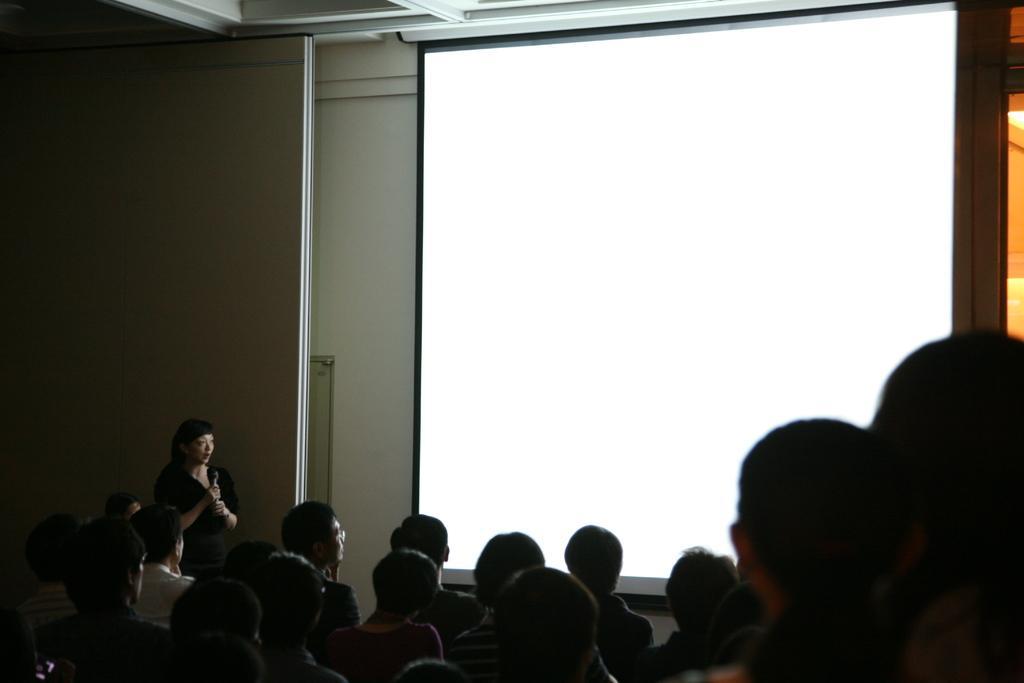Please provide a concise description of this image. In this picture I can see a projector screen. Here I can see a group of people and a woman is standing beside a wall. 